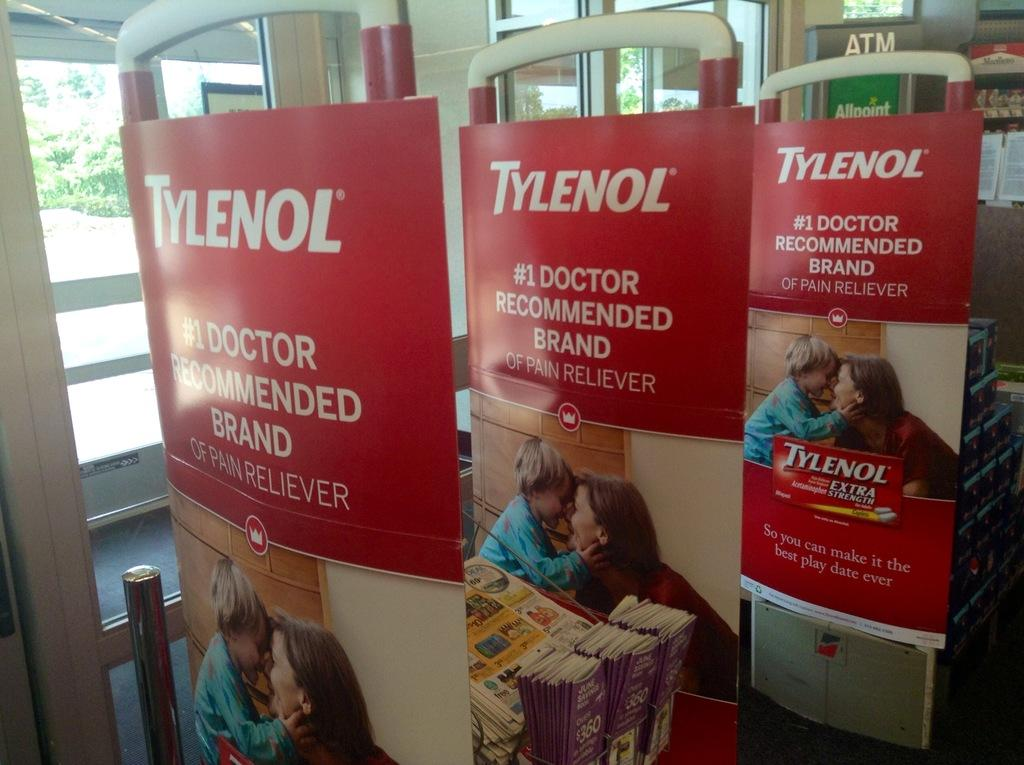<image>
Offer a succinct explanation of the picture presented. Signs for Tylenol says that it's a doctor-recommended brand. 